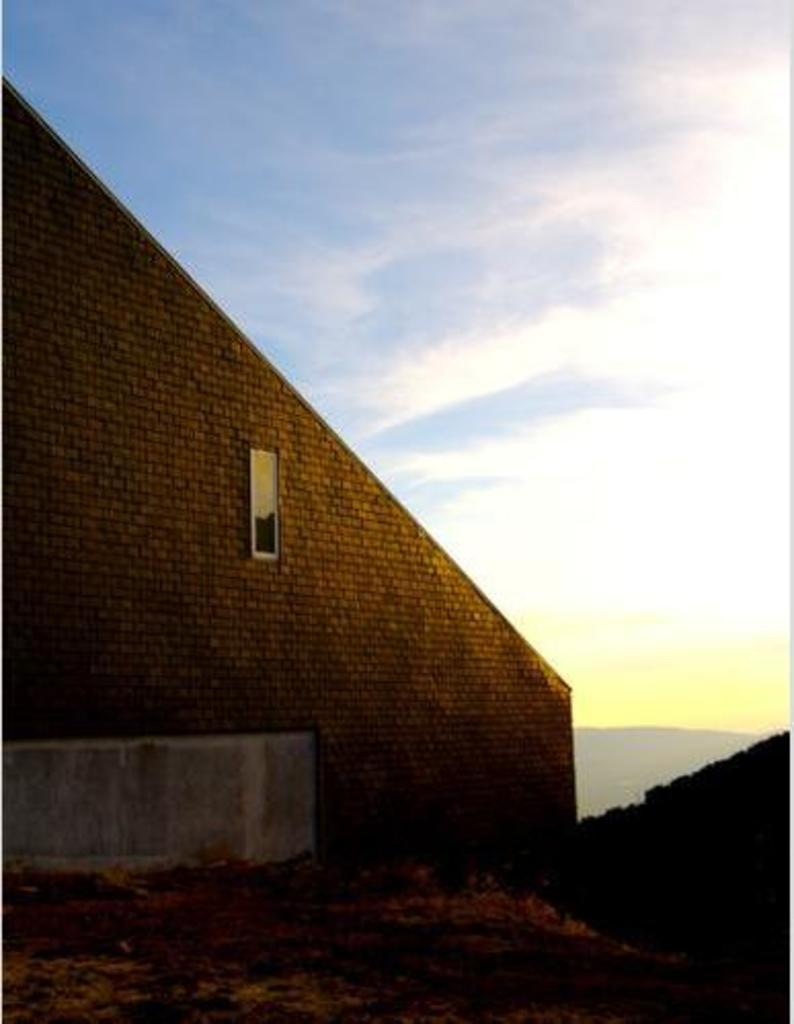What is the color of the wall in the image? There is a brown color wall in the image. What architectural feature can be seen in the wall? There is a window in the wall. What can be seen in the sky in the image? The sky is blue and white in the image. Can you see any deer in the image? There are no deer present in the image. Is there a cemetery visible in the image? There is no cemetery present in the image. 